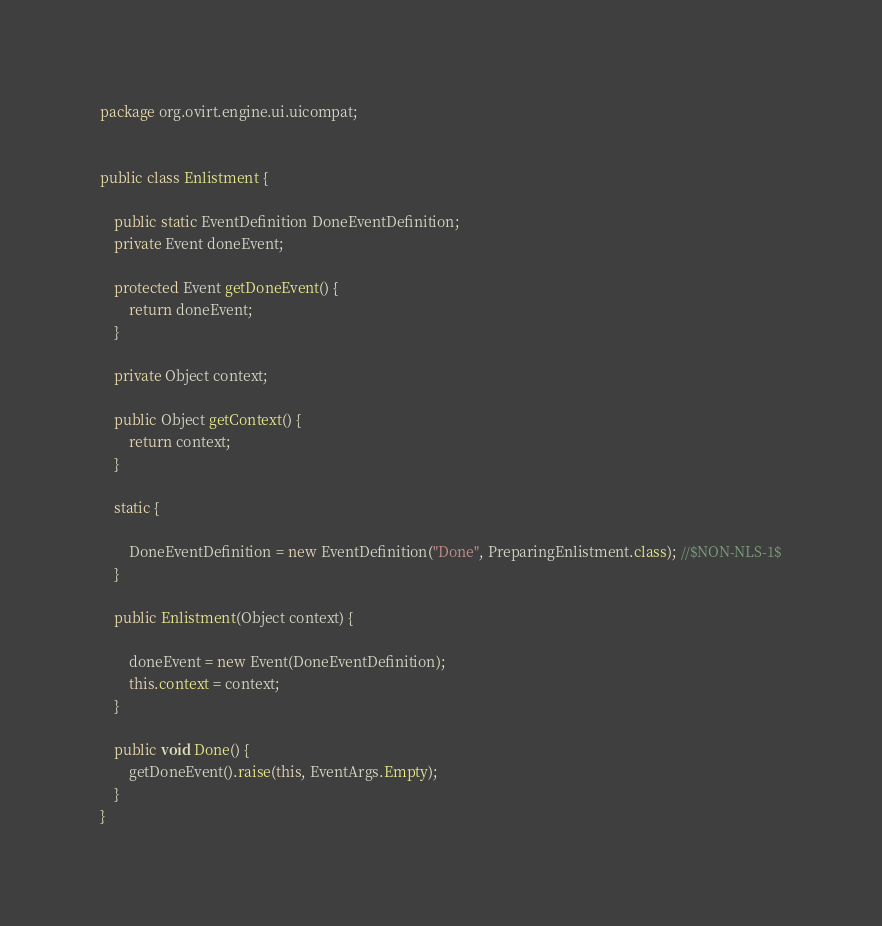Convert code to text. <code><loc_0><loc_0><loc_500><loc_500><_Java_>package org.ovirt.engine.ui.uicompat;


public class Enlistment {

    public static EventDefinition DoneEventDefinition;
    private Event doneEvent;

    protected Event getDoneEvent() {
        return doneEvent;
    }

    private Object context;

    public Object getContext() {
        return context;
    }

    static {

        DoneEventDefinition = new EventDefinition("Done", PreparingEnlistment.class); //$NON-NLS-1$
    }

    public Enlistment(Object context) {

        doneEvent = new Event(DoneEventDefinition);
        this.context = context;
    }

    public void Done() {
        getDoneEvent().raise(this, EventArgs.Empty);
    }
}
</code> 